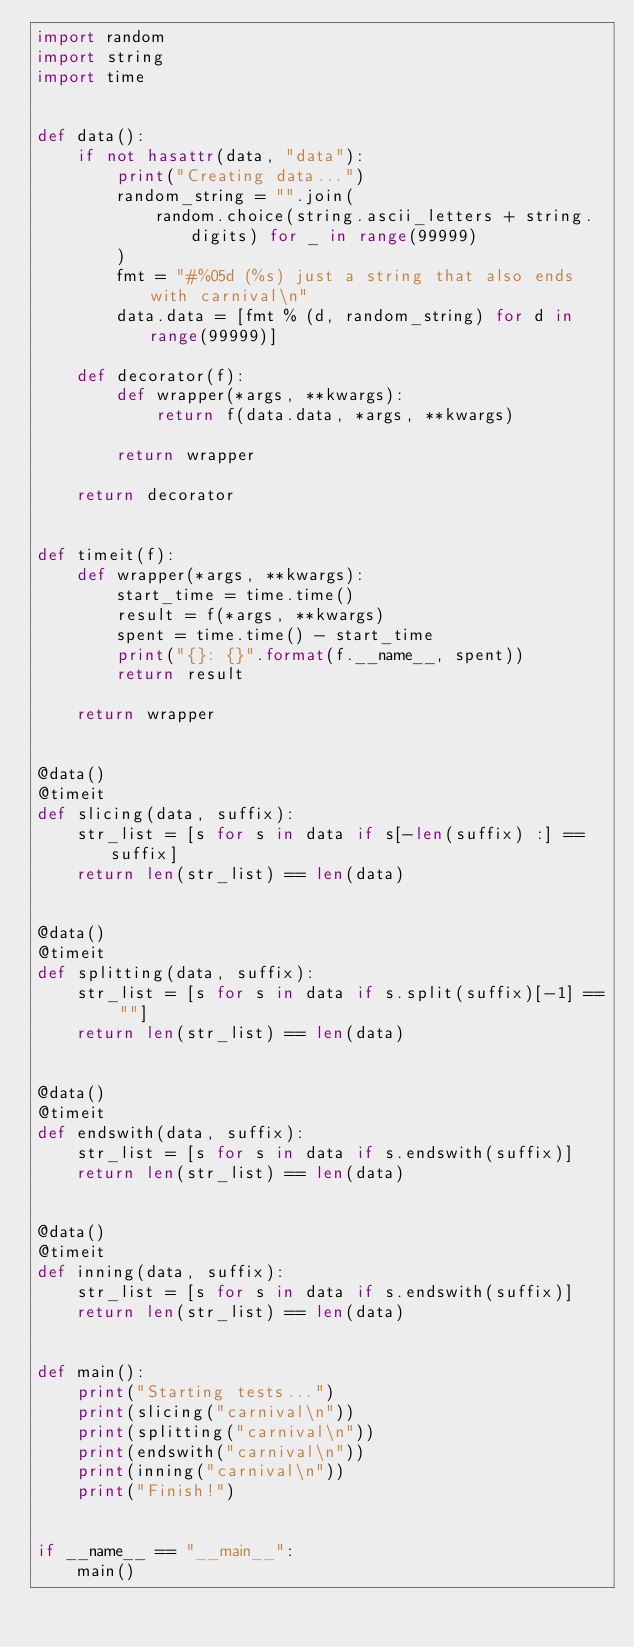Convert code to text. <code><loc_0><loc_0><loc_500><loc_500><_Python_>import random
import string
import time


def data():
    if not hasattr(data, "data"):
        print("Creating data...")
        random_string = "".join(
            random.choice(string.ascii_letters + string.digits) for _ in range(99999)
        )
        fmt = "#%05d (%s) just a string that also ends with carnival\n"
        data.data = [fmt % (d, random_string) for d in range(99999)]

    def decorator(f):
        def wrapper(*args, **kwargs):
            return f(data.data, *args, **kwargs)

        return wrapper

    return decorator


def timeit(f):
    def wrapper(*args, **kwargs):
        start_time = time.time()
        result = f(*args, **kwargs)
        spent = time.time() - start_time
        print("{}: {}".format(f.__name__, spent))
        return result

    return wrapper


@data()
@timeit
def slicing(data, suffix):
    str_list = [s for s in data if s[-len(suffix) :] == suffix]
    return len(str_list) == len(data)


@data()
@timeit
def splitting(data, suffix):
    str_list = [s for s in data if s.split(suffix)[-1] == ""]
    return len(str_list) == len(data)


@data()
@timeit
def endswith(data, suffix):
    str_list = [s for s in data if s.endswith(suffix)]
    return len(str_list) == len(data)


@data()
@timeit
def inning(data, suffix):
    str_list = [s for s in data if s.endswith(suffix)]
    return len(str_list) == len(data)


def main():
    print("Starting tests...")
    print(slicing("carnival\n"))
    print(splitting("carnival\n"))
    print(endswith("carnival\n"))
    print(inning("carnival\n"))
    print("Finish!")


if __name__ == "__main__":
    main()
</code> 